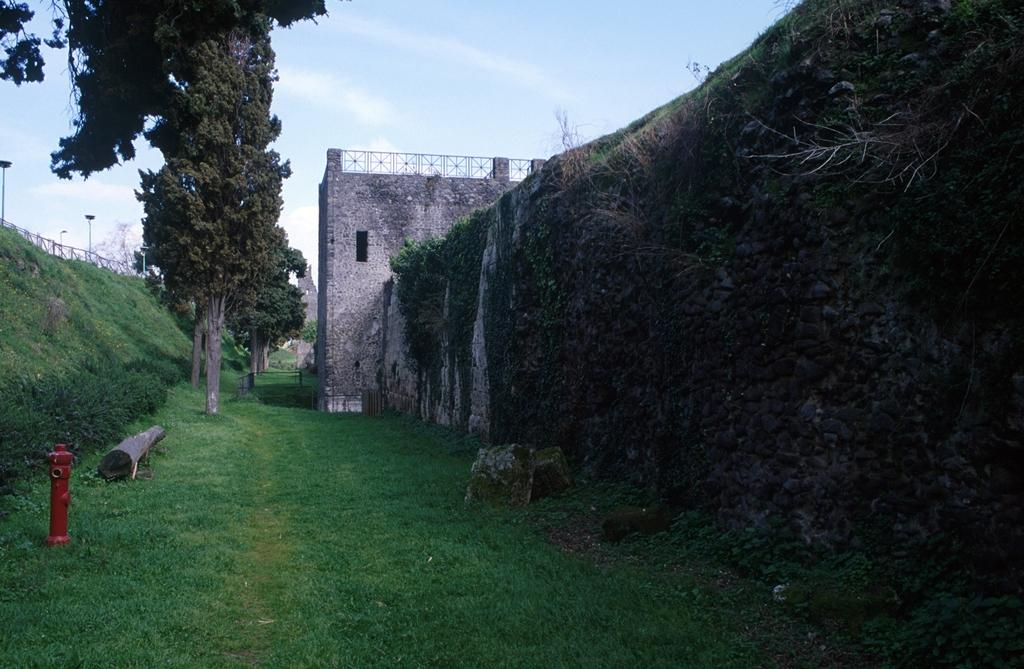What type of vegetation can be seen in the image? There is grass in the image. What other natural elements are present in the image? There are rocks, trees, and clouds visible in the image. What man-made structures can be seen in the image? Street poles, a fence, and a hydrant are visible in the image. What is on the wall in the image? Creepers are present on the wall. What is visible in the sky in the image? The sky is visible in the image, and clouds are present. How many pizzas are being served on the hydrant in the image? There are no pizzas present in the image, and the hydrant is not serving any food. 